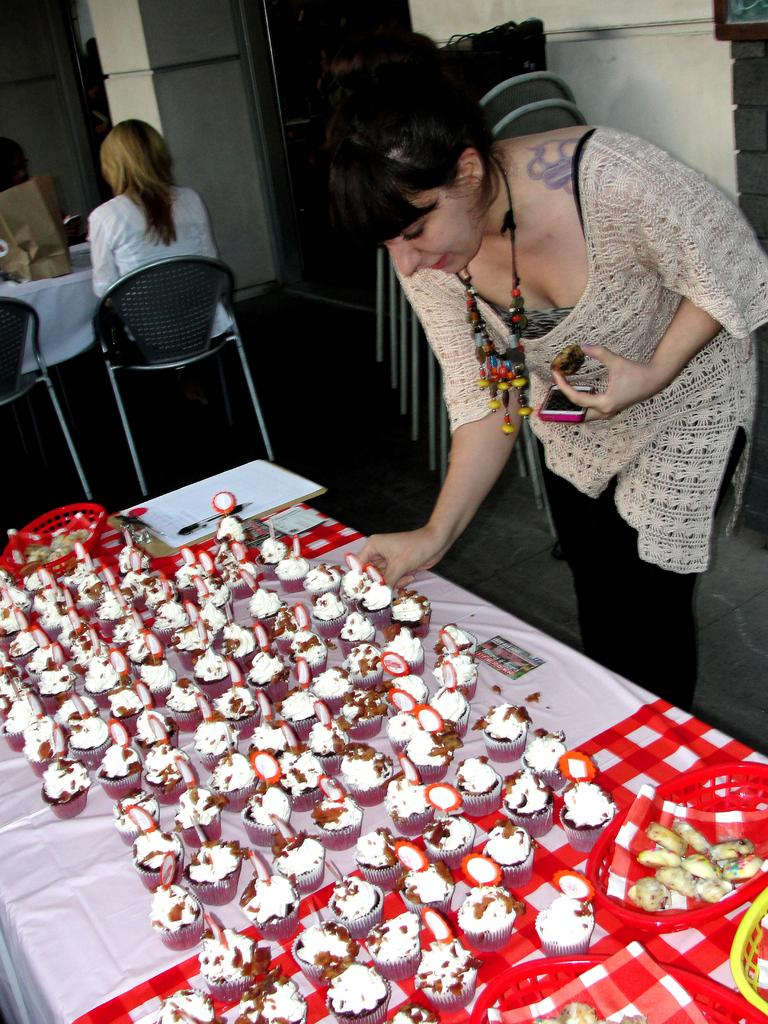What is the main subject in the image? There is a woman standing in the image. What can be seen on the table in the image? There are cupcakes on the table. Where is the woman sitting in the image? The woman is sitting on a chair at the back of the image. What type of hole can be seen in the image? There is no hole present in the image. What cable is the woman using to attack the cupcakes in the image? There is no cable or attack depicted in the image; the woman is simply sitting on a chair. 